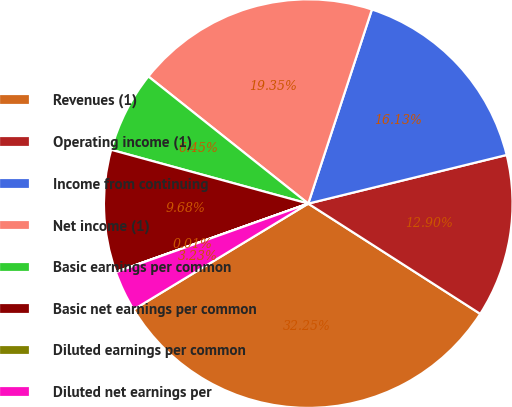Convert chart. <chart><loc_0><loc_0><loc_500><loc_500><pie_chart><fcel>Revenues (1)<fcel>Operating income (1)<fcel>Income from continuing<fcel>Net income (1)<fcel>Basic earnings per common<fcel>Basic net earnings per common<fcel>Diluted earnings per common<fcel>Diluted net earnings per<nl><fcel>32.25%<fcel>12.9%<fcel>16.13%<fcel>19.35%<fcel>6.45%<fcel>9.68%<fcel>0.01%<fcel>3.23%<nl></chart> 